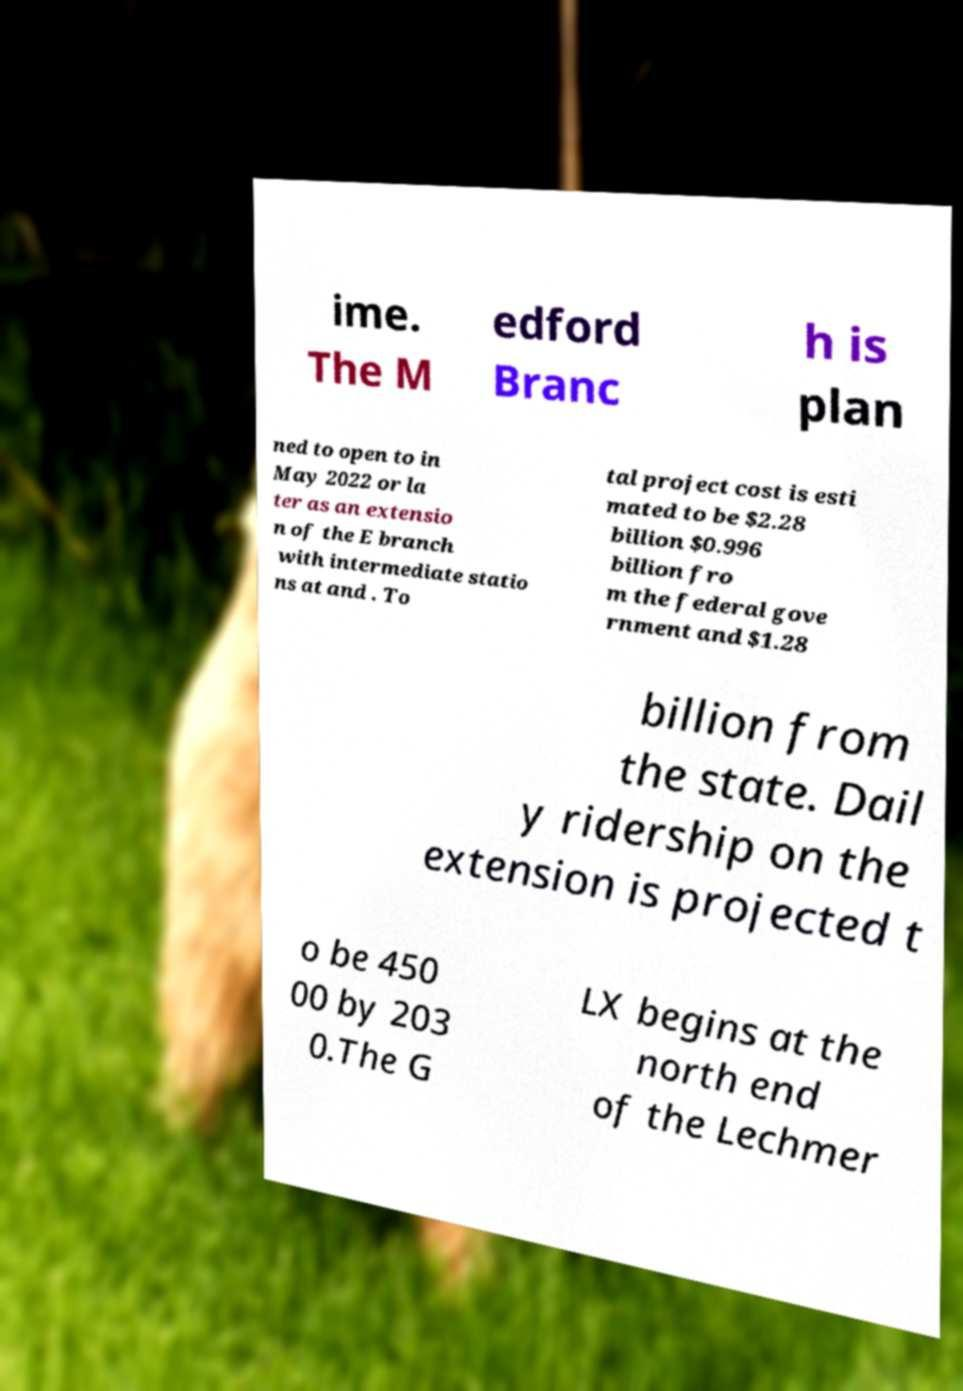There's text embedded in this image that I need extracted. Can you transcribe it verbatim? ime. The M edford Branc h is plan ned to open to in May 2022 or la ter as an extensio n of the E branch with intermediate statio ns at and . To tal project cost is esti mated to be $2.28 billion $0.996 billion fro m the federal gove rnment and $1.28 billion from the state. Dail y ridership on the extension is projected t o be 450 00 by 203 0.The G LX begins at the north end of the Lechmer 